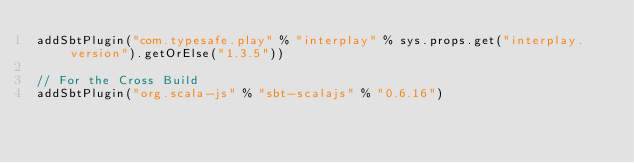<code> <loc_0><loc_0><loc_500><loc_500><_Scala_>addSbtPlugin("com.typesafe.play" % "interplay" % sys.props.get("interplay.version").getOrElse("1.3.5"))

// For the Cross Build
addSbtPlugin("org.scala-js" % "sbt-scalajs" % "0.6.16")
</code> 